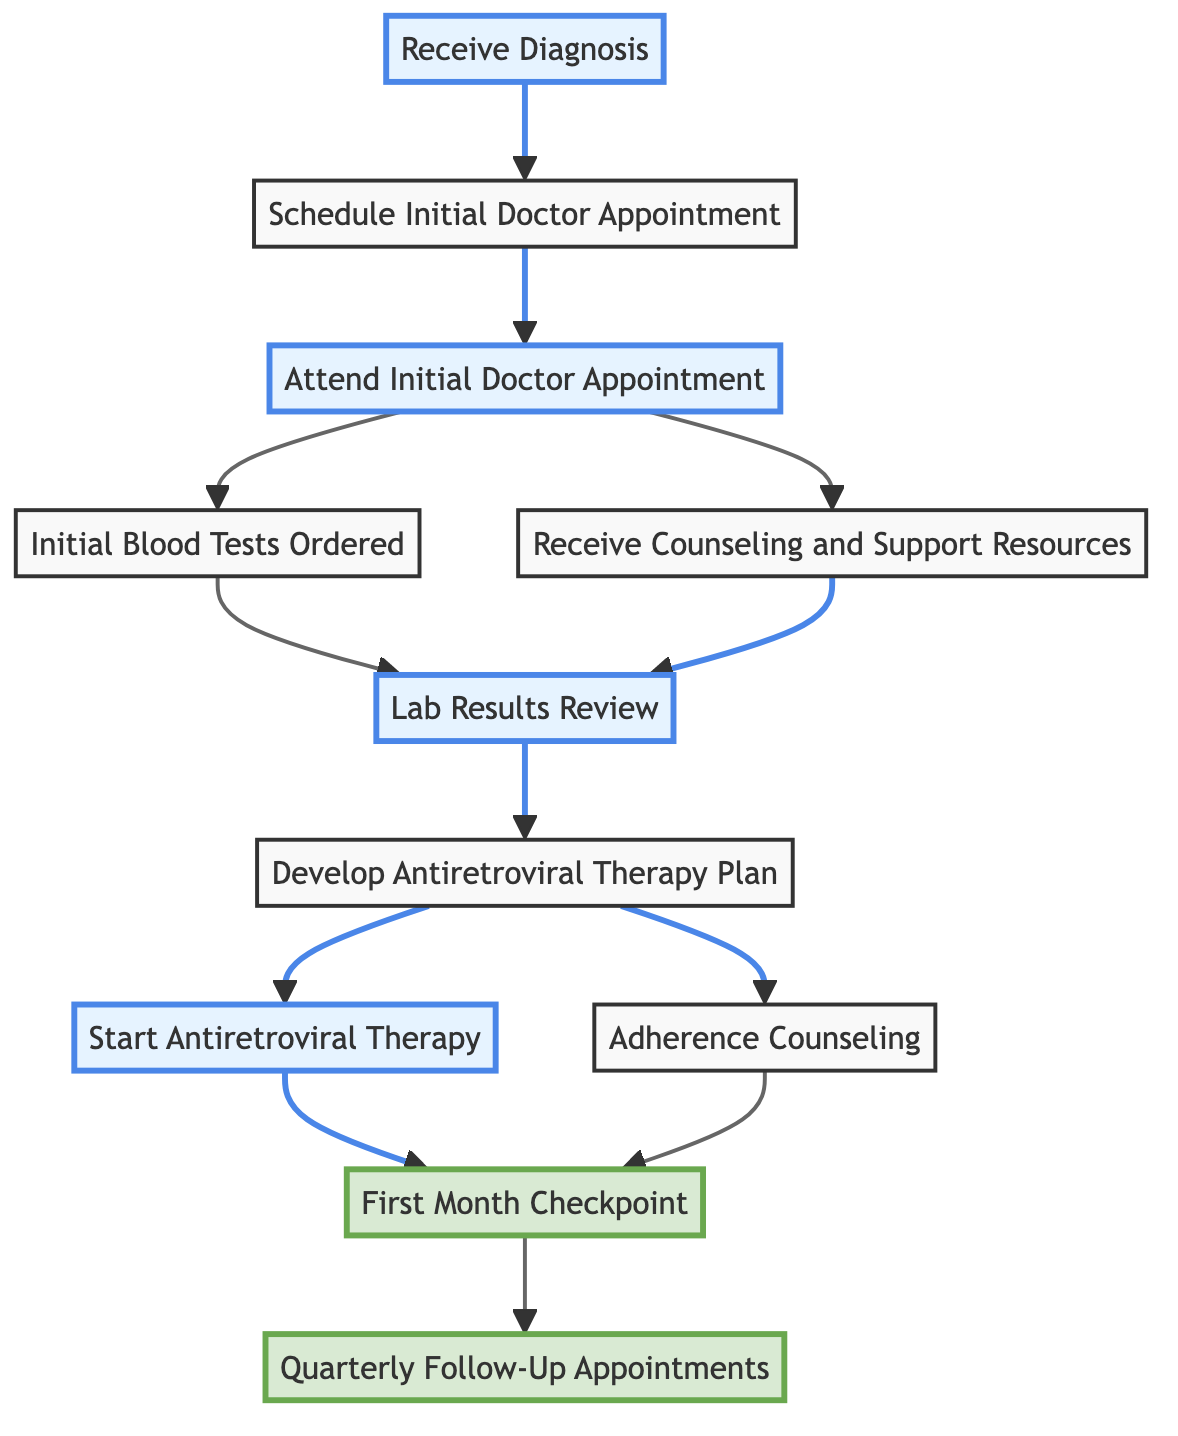What is the first step after receiving a diagnosis? The first step outlined in the flow chart is to "Schedule Initial Doctor Appointment," immediately following "Receive Diagnosis."
Answer: Schedule Initial Doctor Appointment How many steps are there after "Lab Results Review"? The flow chart shows two next steps after "Lab Results Review," which are "Develop Antiretroviral Therapy Plan."
Answer: 2 Which step involves starting medication? The step that involves starting medication is "Start Antiretroviral Therapy," which follows "Develop Antiretroviral Therapy Plan."
Answer: Start Antiretroviral Therapy What connections are made from "Attend Initial Doctor Appointment"? From "Attend Initial Doctor Appointment," there are two connections made: one to "Initial Blood Tests Ordered" and another to "Receive Counseling and Support Resources."
Answer: Initial Blood Tests Ordered and Receive Counseling and Support Resources What is the milestone checkpoint in the flow chart? The milestone checkpoint identified in the flow chart is "First Month Checkpoint," which follows both "Start Antiretroviral Therapy" and "Adherence Counseling."
Answer: First Month Checkpoint What step follows "Develop Antiretroviral Therapy Plan"? The step that directly follows "Develop Antiretroviral Therapy Plan" is "Start Antiretroviral Therapy."
Answer: Start Antiretroviral Therapy How often are follow-up appointments scheduled after the first month? The flow chart indicates that follow-up appointments are scheduled quarterly, meaning every three months after the "First Month Checkpoint."
Answer: Quarterly Which two steps can occur simultaneously after attending the initial doctor appointment? After attending the initial doctor appointment, the two steps that can occur simultaneously are "Initial Blood Tests Ordered" and "Receive Counseling and Support Resources."
Answer: Initial Blood Tests Ordered and Receive Counseling and Support Resources What does "Adherence Counseling" provide? "Adherence Counseling" provides guidance on the importance of medication adherence and strategies for ensuring consistent medication-taking.
Answer: Guidance on medication adherence 